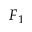Convert formula to latex. <formula><loc_0><loc_0><loc_500><loc_500>F _ { 1 }</formula> 